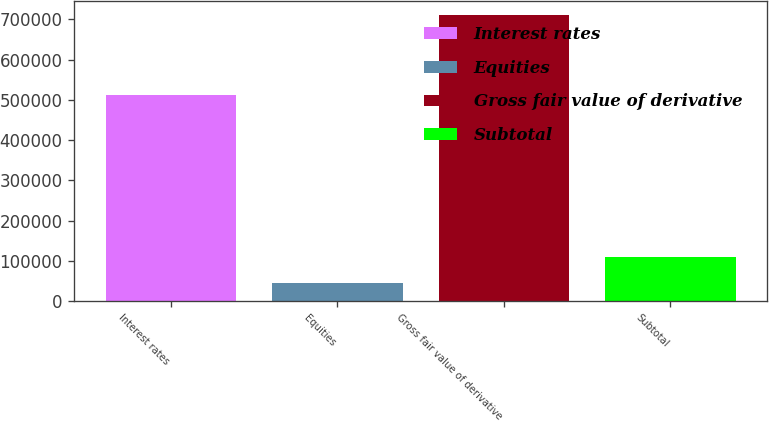<chart> <loc_0><loc_0><loc_500><loc_500><bar_chart><fcel>Interest rates<fcel>Equities<fcel>Gross fair value of derivative<fcel>Subtotal<nl><fcel>513275<fcel>43953<fcel>710345<fcel>110592<nl></chart> 